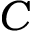<formula> <loc_0><loc_0><loc_500><loc_500>C</formula> 